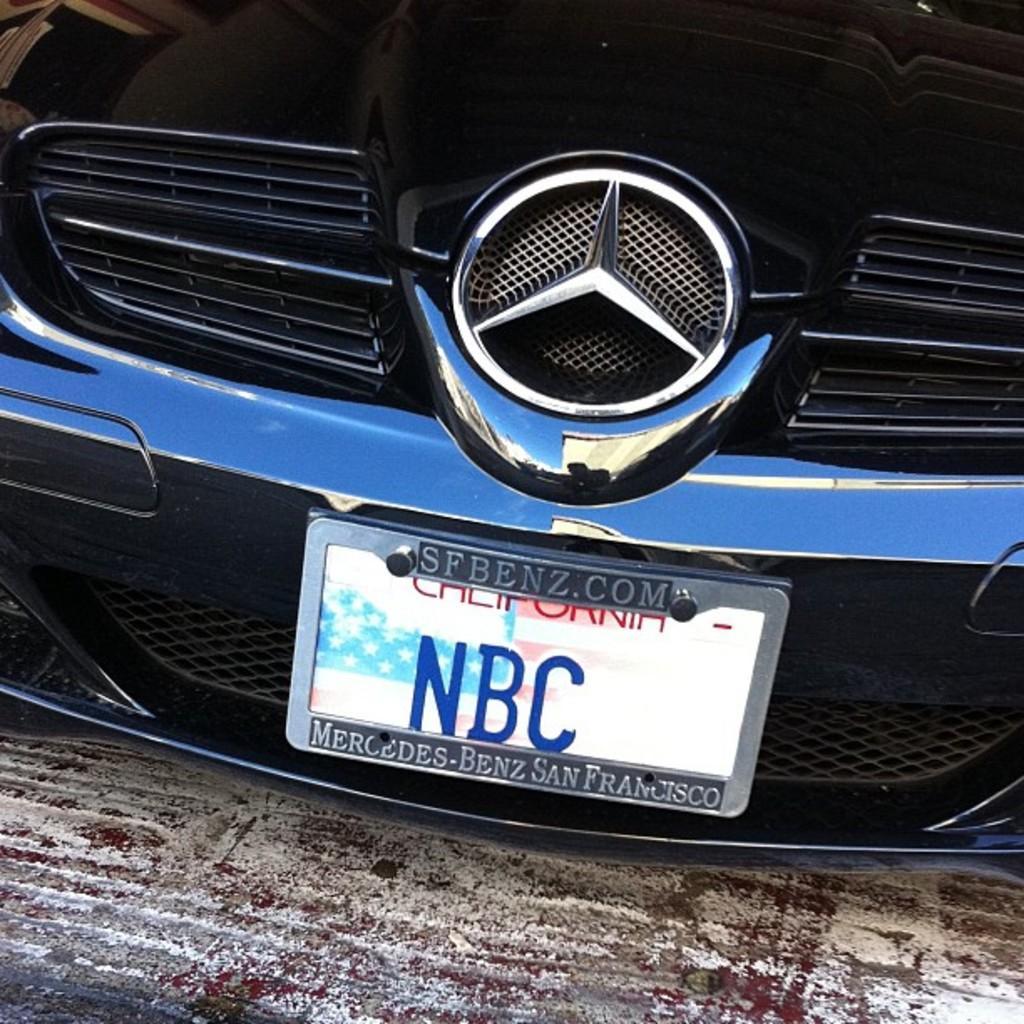Can you describe this image briefly? In this image we can see a car with a logo and a registration plate on the ground. 